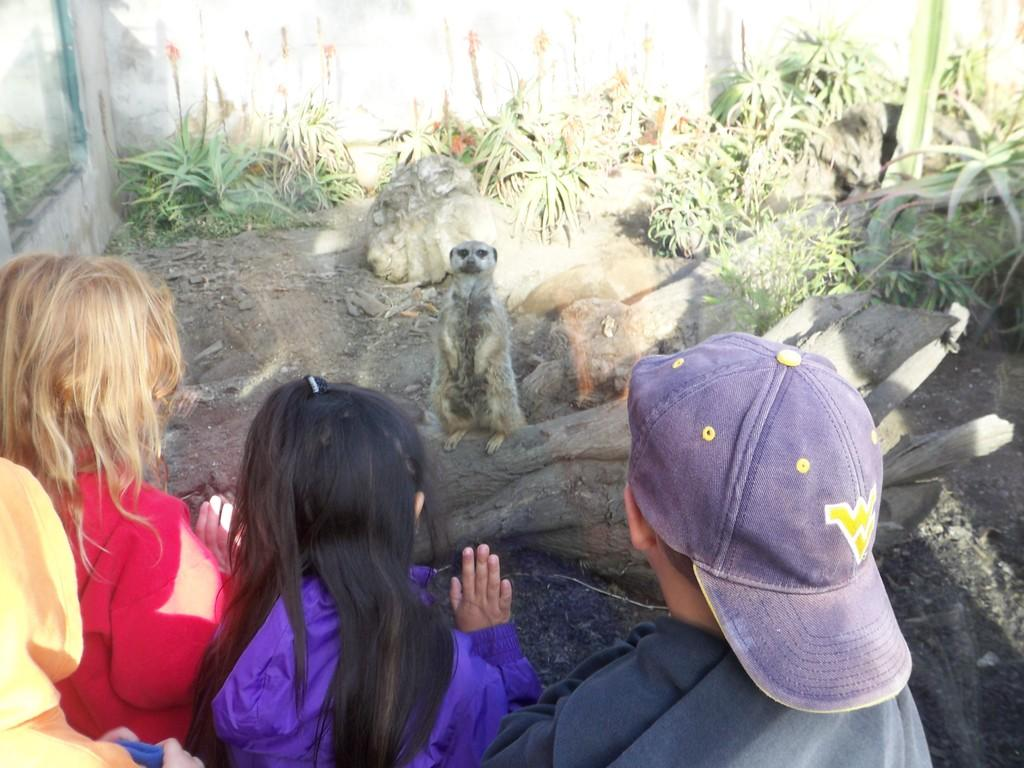What animal is the main subject of the image? There is a Meerkat standing on a tree bark in the image. What are the people in the image doing? The people in the image are looking at the Meerkat. What type of vegetation is on the right side of the image? There are plants on the right side of the image. What type of vessel is being used to heat the Meerkat in the image? There is no vessel or heating element present in the image; the Meerkat is standing on a tree bark. How many cans of food are visible in the image? There are no cans of food present in the image. 